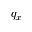Convert formula to latex. <formula><loc_0><loc_0><loc_500><loc_500>q _ { x }</formula> 